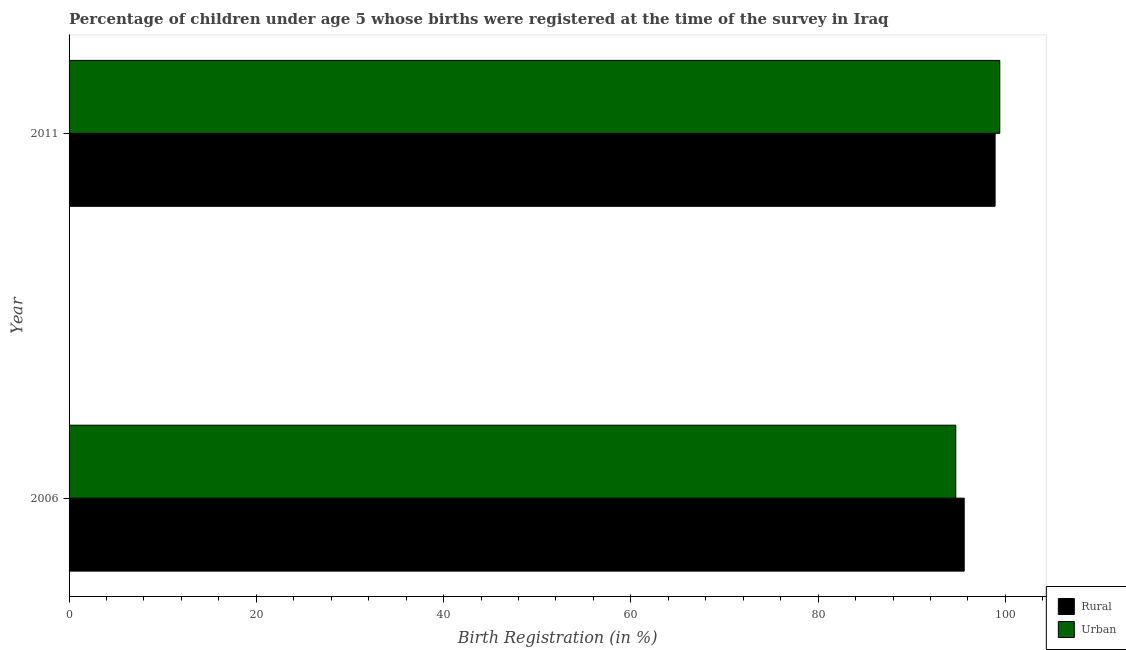How many different coloured bars are there?
Keep it short and to the point. 2. How many bars are there on the 2nd tick from the top?
Ensure brevity in your answer.  2. In how many cases, is the number of bars for a given year not equal to the number of legend labels?
Offer a terse response. 0. What is the rural birth registration in 2011?
Give a very brief answer. 98.9. Across all years, what is the maximum urban birth registration?
Your response must be concise. 99.4. Across all years, what is the minimum urban birth registration?
Your answer should be very brief. 94.7. What is the total rural birth registration in the graph?
Provide a short and direct response. 194.5. What is the difference between the rural birth registration in 2006 and the urban birth registration in 2011?
Provide a short and direct response. -3.8. What is the average urban birth registration per year?
Give a very brief answer. 97.05. What is the ratio of the urban birth registration in 2006 to that in 2011?
Your answer should be compact. 0.95. Is the urban birth registration in 2006 less than that in 2011?
Offer a very short reply. Yes. In how many years, is the urban birth registration greater than the average urban birth registration taken over all years?
Your answer should be compact. 1. What does the 1st bar from the top in 2011 represents?
Keep it short and to the point. Urban. What does the 2nd bar from the bottom in 2006 represents?
Offer a terse response. Urban. How many years are there in the graph?
Provide a succinct answer. 2. Are the values on the major ticks of X-axis written in scientific E-notation?
Keep it short and to the point. No. Does the graph contain any zero values?
Offer a terse response. No. How many legend labels are there?
Give a very brief answer. 2. How are the legend labels stacked?
Keep it short and to the point. Vertical. What is the title of the graph?
Your answer should be very brief. Percentage of children under age 5 whose births were registered at the time of the survey in Iraq. What is the label or title of the X-axis?
Your response must be concise. Birth Registration (in %). What is the Birth Registration (in %) of Rural in 2006?
Your answer should be very brief. 95.6. What is the Birth Registration (in %) in Urban in 2006?
Give a very brief answer. 94.7. What is the Birth Registration (in %) in Rural in 2011?
Your answer should be very brief. 98.9. What is the Birth Registration (in %) in Urban in 2011?
Ensure brevity in your answer.  99.4. Across all years, what is the maximum Birth Registration (in %) of Rural?
Ensure brevity in your answer.  98.9. Across all years, what is the maximum Birth Registration (in %) in Urban?
Your answer should be very brief. 99.4. Across all years, what is the minimum Birth Registration (in %) of Rural?
Provide a short and direct response. 95.6. Across all years, what is the minimum Birth Registration (in %) in Urban?
Ensure brevity in your answer.  94.7. What is the total Birth Registration (in %) in Rural in the graph?
Keep it short and to the point. 194.5. What is the total Birth Registration (in %) in Urban in the graph?
Offer a very short reply. 194.1. What is the difference between the Birth Registration (in %) of Rural in 2006 and that in 2011?
Ensure brevity in your answer.  -3.3. What is the difference between the Birth Registration (in %) in Rural in 2006 and the Birth Registration (in %) in Urban in 2011?
Your answer should be compact. -3.8. What is the average Birth Registration (in %) in Rural per year?
Your answer should be very brief. 97.25. What is the average Birth Registration (in %) in Urban per year?
Provide a short and direct response. 97.05. In the year 2006, what is the difference between the Birth Registration (in %) in Rural and Birth Registration (in %) in Urban?
Ensure brevity in your answer.  0.9. What is the ratio of the Birth Registration (in %) in Rural in 2006 to that in 2011?
Your response must be concise. 0.97. What is the ratio of the Birth Registration (in %) of Urban in 2006 to that in 2011?
Offer a terse response. 0.95. What is the difference between the highest and the second highest Birth Registration (in %) of Rural?
Offer a very short reply. 3.3. What is the difference between the highest and the lowest Birth Registration (in %) of Urban?
Your answer should be very brief. 4.7. 